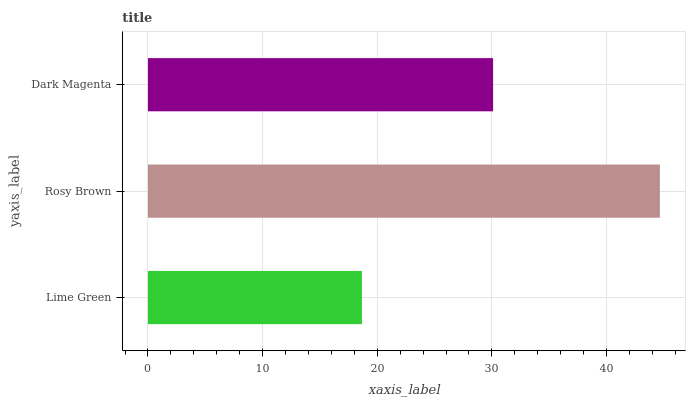Is Lime Green the minimum?
Answer yes or no. Yes. Is Rosy Brown the maximum?
Answer yes or no. Yes. Is Dark Magenta the minimum?
Answer yes or no. No. Is Dark Magenta the maximum?
Answer yes or no. No. Is Rosy Brown greater than Dark Magenta?
Answer yes or no. Yes. Is Dark Magenta less than Rosy Brown?
Answer yes or no. Yes. Is Dark Magenta greater than Rosy Brown?
Answer yes or no. No. Is Rosy Brown less than Dark Magenta?
Answer yes or no. No. Is Dark Magenta the high median?
Answer yes or no. Yes. Is Dark Magenta the low median?
Answer yes or no. Yes. Is Rosy Brown the high median?
Answer yes or no. No. Is Rosy Brown the low median?
Answer yes or no. No. 